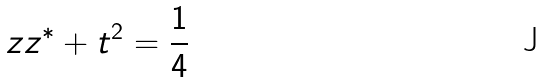Convert formula to latex. <formula><loc_0><loc_0><loc_500><loc_500>z z ^ { * } + t ^ { 2 } = \frac { 1 } { 4 }</formula> 